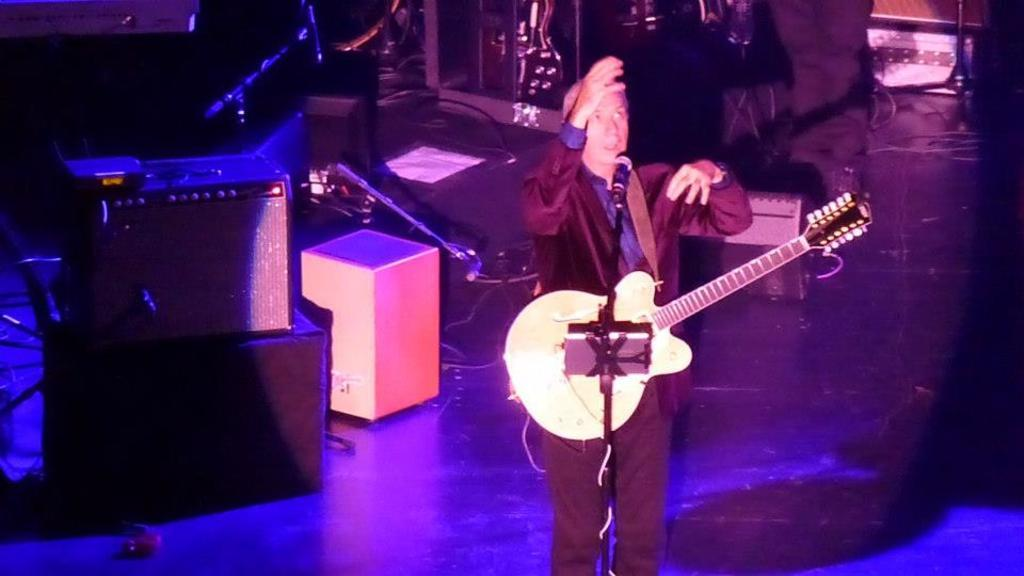What is the man in the image holding? The man is holding a guitar in the image. What is the man doing with the guitar? The man is standing with a guitar, which suggests he might be playing or about to play it. What object is near the man in the image? The man is near a microphone in the image. What can be seen in the background of the image? There are speakers and cables in the background of the image. What type of box is the man using to cast a spell in the image? There is no box or spell casting in the image; the man is holding a guitar and standing near a microphone. 